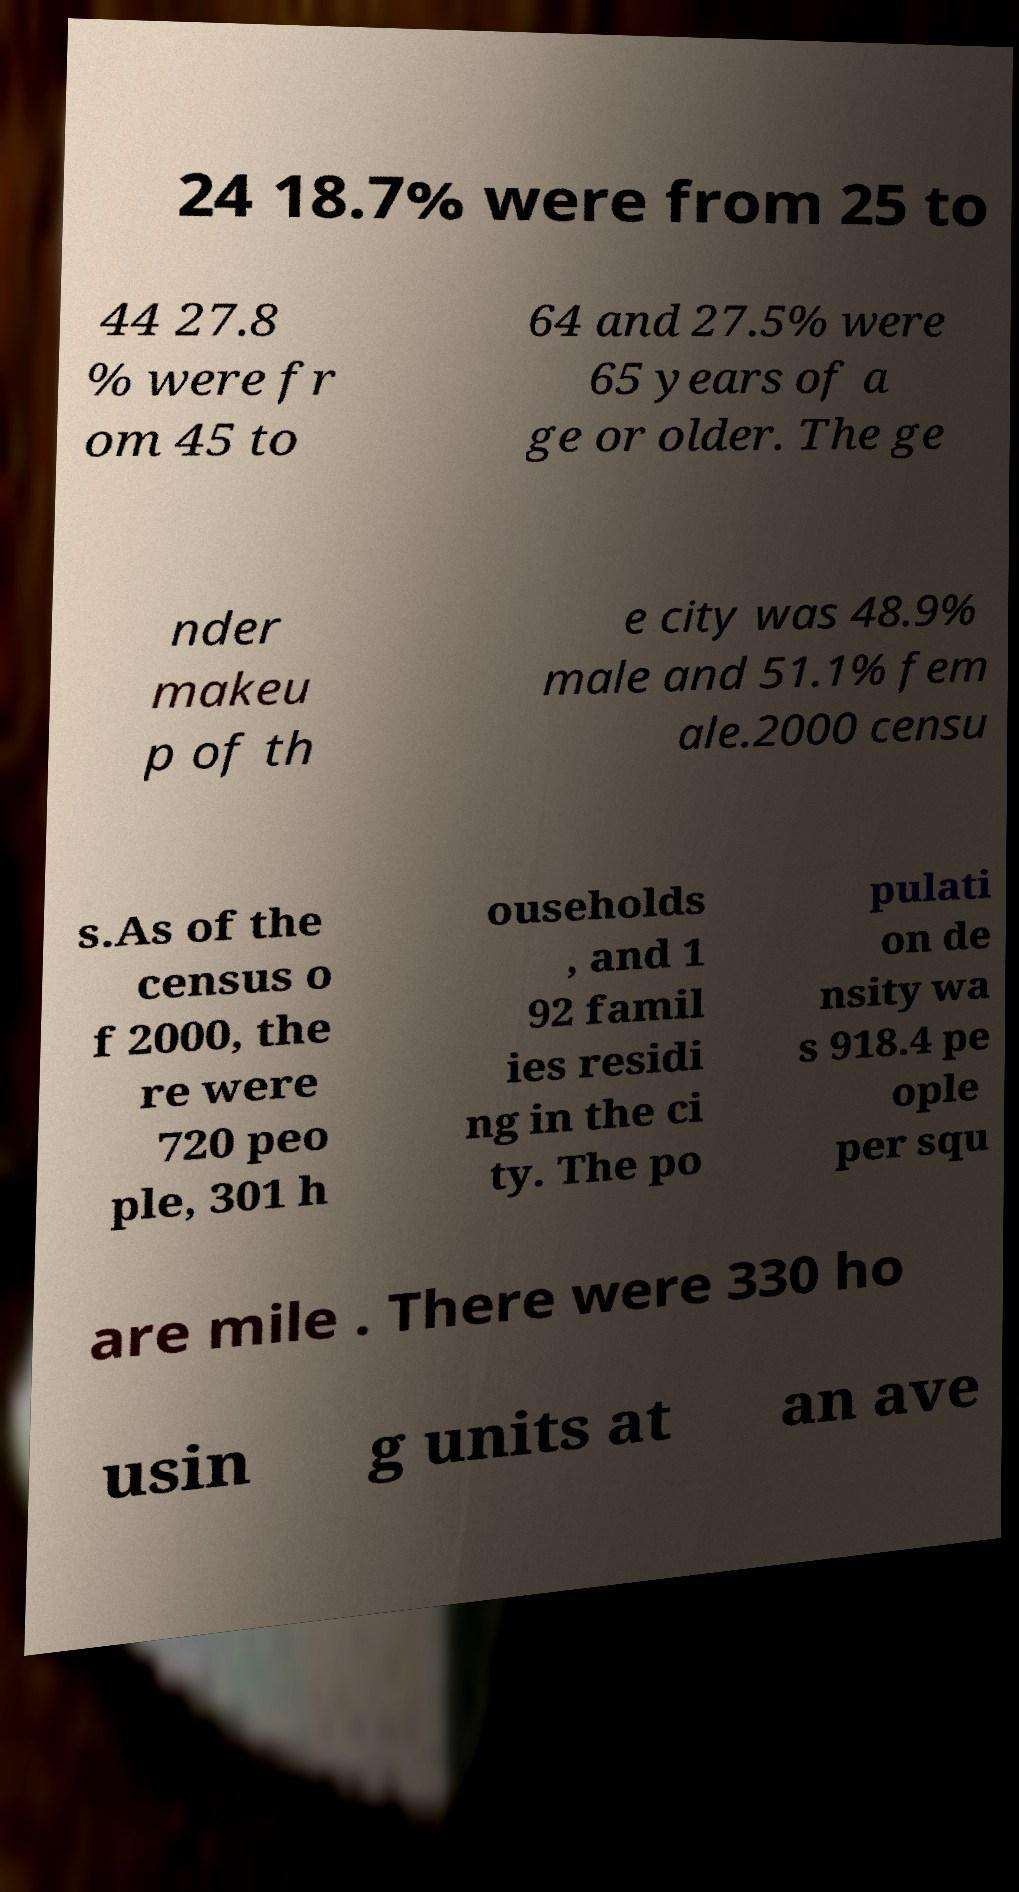Please identify and transcribe the text found in this image. 24 18.7% were from 25 to 44 27.8 % were fr om 45 to 64 and 27.5% were 65 years of a ge or older. The ge nder makeu p of th e city was 48.9% male and 51.1% fem ale.2000 censu s.As of the census o f 2000, the re were 720 peo ple, 301 h ouseholds , and 1 92 famil ies residi ng in the ci ty. The po pulati on de nsity wa s 918.4 pe ople per squ are mile . There were 330 ho usin g units at an ave 